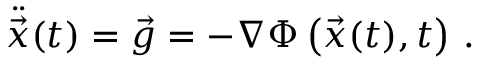Convert formula to latex. <formula><loc_0><loc_0><loc_500><loc_500>{ \ddot { \vec { x } } } ( t ) = { \vec { g } } = - \nabla \Phi \left ( { \vec { x } } ( t ) , t \right ) \, .</formula> 